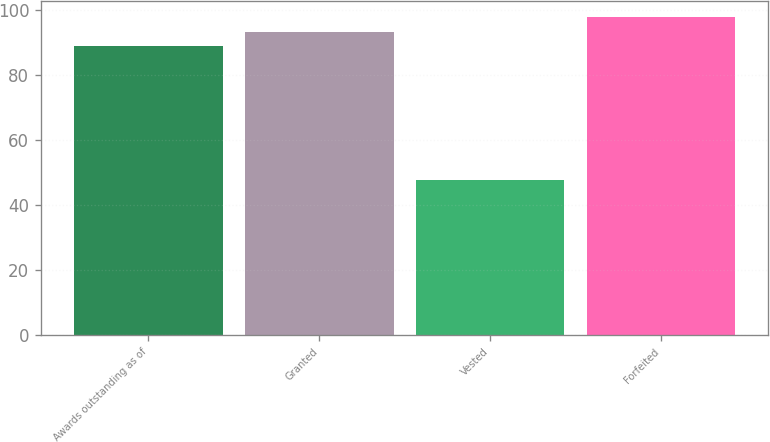Convert chart to OTSL. <chart><loc_0><loc_0><loc_500><loc_500><bar_chart><fcel>Awards outstanding as of<fcel>Granted<fcel>Vested<fcel>Forfeited<nl><fcel>88.75<fcel>93.17<fcel>47.71<fcel>97.59<nl></chart> 